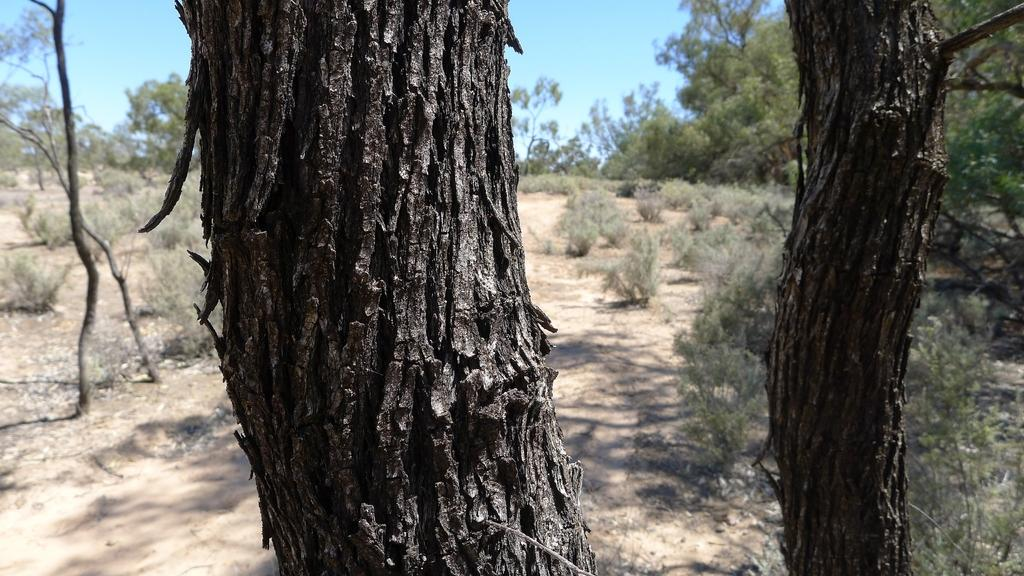What type of vegetation can be seen in the image? There are trees and shrubs in the image. What can be seen in the background of the image? The sky is visible in the background of the image. What type of ice can be seen rolling down the trees in the image? There is no ice present in the image, and the trees are not depicted as rolling. 